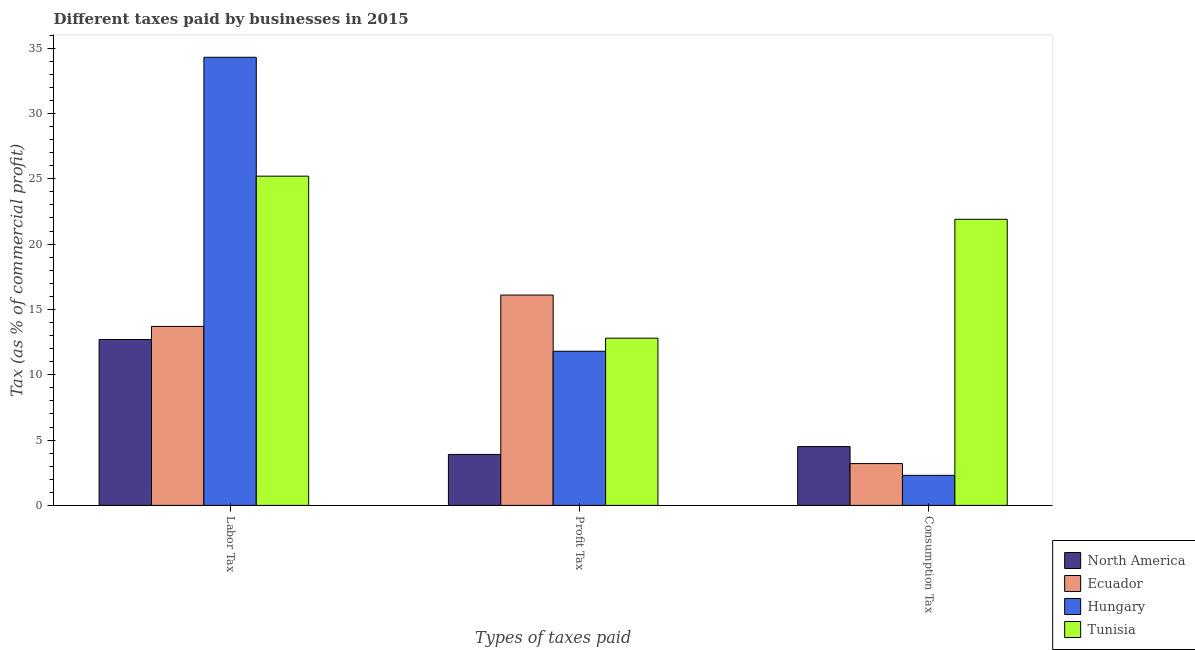How many different coloured bars are there?
Your answer should be compact. 4. How many groups of bars are there?
Your answer should be compact. 3. Are the number of bars per tick equal to the number of legend labels?
Make the answer very short. Yes. What is the label of the 3rd group of bars from the left?
Offer a terse response. Consumption Tax. What is the percentage of profit tax in Ecuador?
Give a very brief answer. 16.1. Across all countries, what is the maximum percentage of consumption tax?
Offer a very short reply. 21.9. In which country was the percentage of labor tax maximum?
Make the answer very short. Hungary. In which country was the percentage of labor tax minimum?
Make the answer very short. North America. What is the total percentage of labor tax in the graph?
Your response must be concise. 85.9. What is the difference between the percentage of labor tax in Tunisia and that in Ecuador?
Your answer should be very brief. 11.5. What is the average percentage of consumption tax per country?
Ensure brevity in your answer.  7.97. What is the difference between the percentage of consumption tax and percentage of profit tax in North America?
Offer a very short reply. 0.6. What is the ratio of the percentage of profit tax in North America to that in Ecuador?
Your answer should be very brief. 0.24. Is the percentage of consumption tax in Tunisia less than that in North America?
Ensure brevity in your answer.  No. What is the difference between the highest and the second highest percentage of labor tax?
Provide a short and direct response. 9.1. What is the difference between the highest and the lowest percentage of profit tax?
Keep it short and to the point. 12.2. In how many countries, is the percentage of profit tax greater than the average percentage of profit tax taken over all countries?
Make the answer very short. 3. Is the sum of the percentage of profit tax in Ecuador and Hungary greater than the maximum percentage of consumption tax across all countries?
Provide a short and direct response. Yes. What does the 3rd bar from the right in Labor Tax represents?
Offer a terse response. Ecuador. How many bars are there?
Provide a succinct answer. 12. Are all the bars in the graph horizontal?
Make the answer very short. No. Does the graph contain any zero values?
Your response must be concise. No. Does the graph contain grids?
Your answer should be very brief. No. Where does the legend appear in the graph?
Your response must be concise. Bottom right. How many legend labels are there?
Your answer should be compact. 4. How are the legend labels stacked?
Your response must be concise. Vertical. What is the title of the graph?
Give a very brief answer. Different taxes paid by businesses in 2015. Does "Central African Republic" appear as one of the legend labels in the graph?
Offer a terse response. No. What is the label or title of the X-axis?
Your answer should be compact. Types of taxes paid. What is the label or title of the Y-axis?
Give a very brief answer. Tax (as % of commercial profit). What is the Tax (as % of commercial profit) of North America in Labor Tax?
Your answer should be compact. 12.7. What is the Tax (as % of commercial profit) of Hungary in Labor Tax?
Provide a succinct answer. 34.3. What is the Tax (as % of commercial profit) of Tunisia in Labor Tax?
Provide a succinct answer. 25.2. What is the Tax (as % of commercial profit) in North America in Profit Tax?
Your answer should be compact. 3.9. What is the Tax (as % of commercial profit) in Tunisia in Profit Tax?
Offer a very short reply. 12.8. What is the Tax (as % of commercial profit) in North America in Consumption Tax?
Ensure brevity in your answer.  4.5. What is the Tax (as % of commercial profit) in Ecuador in Consumption Tax?
Your answer should be compact. 3.2. What is the Tax (as % of commercial profit) of Tunisia in Consumption Tax?
Make the answer very short. 21.9. Across all Types of taxes paid, what is the maximum Tax (as % of commercial profit) of Hungary?
Give a very brief answer. 34.3. Across all Types of taxes paid, what is the maximum Tax (as % of commercial profit) in Tunisia?
Give a very brief answer. 25.2. Across all Types of taxes paid, what is the minimum Tax (as % of commercial profit) of Tunisia?
Your response must be concise. 12.8. What is the total Tax (as % of commercial profit) in North America in the graph?
Offer a very short reply. 21.1. What is the total Tax (as % of commercial profit) in Hungary in the graph?
Your response must be concise. 48.4. What is the total Tax (as % of commercial profit) of Tunisia in the graph?
Keep it short and to the point. 59.9. What is the difference between the Tax (as % of commercial profit) in North America in Labor Tax and that in Profit Tax?
Provide a short and direct response. 8.8. What is the difference between the Tax (as % of commercial profit) of Ecuador in Labor Tax and that in Profit Tax?
Give a very brief answer. -2.4. What is the difference between the Tax (as % of commercial profit) of Hungary in Labor Tax and that in Profit Tax?
Provide a short and direct response. 22.5. What is the difference between the Tax (as % of commercial profit) of Tunisia in Labor Tax and that in Profit Tax?
Keep it short and to the point. 12.4. What is the difference between the Tax (as % of commercial profit) of North America in Labor Tax and that in Consumption Tax?
Your answer should be compact. 8.2. What is the difference between the Tax (as % of commercial profit) of Ecuador in Labor Tax and that in Consumption Tax?
Your response must be concise. 10.5. What is the difference between the Tax (as % of commercial profit) in Tunisia in Labor Tax and that in Consumption Tax?
Keep it short and to the point. 3.3. What is the difference between the Tax (as % of commercial profit) in North America in Profit Tax and that in Consumption Tax?
Ensure brevity in your answer.  -0.6. What is the difference between the Tax (as % of commercial profit) of Ecuador in Profit Tax and that in Consumption Tax?
Your answer should be very brief. 12.9. What is the difference between the Tax (as % of commercial profit) of Hungary in Profit Tax and that in Consumption Tax?
Your answer should be compact. 9.5. What is the difference between the Tax (as % of commercial profit) of Tunisia in Profit Tax and that in Consumption Tax?
Provide a short and direct response. -9.1. What is the difference between the Tax (as % of commercial profit) in North America in Labor Tax and the Tax (as % of commercial profit) in Hungary in Profit Tax?
Make the answer very short. 0.9. What is the difference between the Tax (as % of commercial profit) of North America in Labor Tax and the Tax (as % of commercial profit) of Tunisia in Profit Tax?
Your answer should be compact. -0.1. What is the difference between the Tax (as % of commercial profit) of Ecuador in Labor Tax and the Tax (as % of commercial profit) of Tunisia in Profit Tax?
Provide a succinct answer. 0.9. What is the difference between the Tax (as % of commercial profit) in North America in Labor Tax and the Tax (as % of commercial profit) in Ecuador in Consumption Tax?
Give a very brief answer. 9.5. What is the difference between the Tax (as % of commercial profit) of North America in Labor Tax and the Tax (as % of commercial profit) of Hungary in Consumption Tax?
Make the answer very short. 10.4. What is the difference between the Tax (as % of commercial profit) of Ecuador in Labor Tax and the Tax (as % of commercial profit) of Tunisia in Consumption Tax?
Give a very brief answer. -8.2. What is the difference between the Tax (as % of commercial profit) in North America in Profit Tax and the Tax (as % of commercial profit) in Hungary in Consumption Tax?
Provide a short and direct response. 1.6. What is the difference between the Tax (as % of commercial profit) in North America in Profit Tax and the Tax (as % of commercial profit) in Tunisia in Consumption Tax?
Offer a very short reply. -18. What is the difference between the Tax (as % of commercial profit) in Ecuador in Profit Tax and the Tax (as % of commercial profit) in Tunisia in Consumption Tax?
Offer a terse response. -5.8. What is the difference between the Tax (as % of commercial profit) of Hungary in Profit Tax and the Tax (as % of commercial profit) of Tunisia in Consumption Tax?
Your answer should be very brief. -10.1. What is the average Tax (as % of commercial profit) in North America per Types of taxes paid?
Your response must be concise. 7.03. What is the average Tax (as % of commercial profit) of Ecuador per Types of taxes paid?
Your answer should be very brief. 11. What is the average Tax (as % of commercial profit) in Hungary per Types of taxes paid?
Provide a short and direct response. 16.13. What is the average Tax (as % of commercial profit) in Tunisia per Types of taxes paid?
Your answer should be very brief. 19.97. What is the difference between the Tax (as % of commercial profit) of North America and Tax (as % of commercial profit) of Ecuador in Labor Tax?
Keep it short and to the point. -1. What is the difference between the Tax (as % of commercial profit) in North America and Tax (as % of commercial profit) in Hungary in Labor Tax?
Provide a succinct answer. -21.6. What is the difference between the Tax (as % of commercial profit) in Ecuador and Tax (as % of commercial profit) in Hungary in Labor Tax?
Make the answer very short. -20.6. What is the difference between the Tax (as % of commercial profit) in Ecuador and Tax (as % of commercial profit) in Tunisia in Labor Tax?
Provide a succinct answer. -11.5. What is the difference between the Tax (as % of commercial profit) in Hungary and Tax (as % of commercial profit) in Tunisia in Labor Tax?
Provide a succinct answer. 9.1. What is the difference between the Tax (as % of commercial profit) in North America and Tax (as % of commercial profit) in Ecuador in Profit Tax?
Provide a short and direct response. -12.2. What is the difference between the Tax (as % of commercial profit) in North America and Tax (as % of commercial profit) in Hungary in Profit Tax?
Your answer should be compact. -7.9. What is the difference between the Tax (as % of commercial profit) of North America and Tax (as % of commercial profit) of Tunisia in Profit Tax?
Your answer should be compact. -8.9. What is the difference between the Tax (as % of commercial profit) of Ecuador and Tax (as % of commercial profit) of Hungary in Profit Tax?
Make the answer very short. 4.3. What is the difference between the Tax (as % of commercial profit) in Hungary and Tax (as % of commercial profit) in Tunisia in Profit Tax?
Provide a short and direct response. -1. What is the difference between the Tax (as % of commercial profit) in North America and Tax (as % of commercial profit) in Ecuador in Consumption Tax?
Ensure brevity in your answer.  1.3. What is the difference between the Tax (as % of commercial profit) in North America and Tax (as % of commercial profit) in Hungary in Consumption Tax?
Your response must be concise. 2.2. What is the difference between the Tax (as % of commercial profit) of North America and Tax (as % of commercial profit) of Tunisia in Consumption Tax?
Provide a short and direct response. -17.4. What is the difference between the Tax (as % of commercial profit) of Ecuador and Tax (as % of commercial profit) of Tunisia in Consumption Tax?
Provide a succinct answer. -18.7. What is the difference between the Tax (as % of commercial profit) in Hungary and Tax (as % of commercial profit) in Tunisia in Consumption Tax?
Offer a terse response. -19.6. What is the ratio of the Tax (as % of commercial profit) of North America in Labor Tax to that in Profit Tax?
Your answer should be very brief. 3.26. What is the ratio of the Tax (as % of commercial profit) in Ecuador in Labor Tax to that in Profit Tax?
Ensure brevity in your answer.  0.85. What is the ratio of the Tax (as % of commercial profit) in Hungary in Labor Tax to that in Profit Tax?
Provide a succinct answer. 2.91. What is the ratio of the Tax (as % of commercial profit) of Tunisia in Labor Tax to that in Profit Tax?
Your answer should be compact. 1.97. What is the ratio of the Tax (as % of commercial profit) in North America in Labor Tax to that in Consumption Tax?
Make the answer very short. 2.82. What is the ratio of the Tax (as % of commercial profit) in Ecuador in Labor Tax to that in Consumption Tax?
Your answer should be compact. 4.28. What is the ratio of the Tax (as % of commercial profit) in Hungary in Labor Tax to that in Consumption Tax?
Make the answer very short. 14.91. What is the ratio of the Tax (as % of commercial profit) in Tunisia in Labor Tax to that in Consumption Tax?
Give a very brief answer. 1.15. What is the ratio of the Tax (as % of commercial profit) of North America in Profit Tax to that in Consumption Tax?
Make the answer very short. 0.87. What is the ratio of the Tax (as % of commercial profit) of Ecuador in Profit Tax to that in Consumption Tax?
Make the answer very short. 5.03. What is the ratio of the Tax (as % of commercial profit) of Hungary in Profit Tax to that in Consumption Tax?
Your answer should be very brief. 5.13. What is the ratio of the Tax (as % of commercial profit) of Tunisia in Profit Tax to that in Consumption Tax?
Your answer should be compact. 0.58. What is the difference between the highest and the second highest Tax (as % of commercial profit) of North America?
Offer a terse response. 8.2. What is the difference between the highest and the second highest Tax (as % of commercial profit) in Ecuador?
Provide a short and direct response. 2.4. What is the difference between the highest and the second highest Tax (as % of commercial profit) in Hungary?
Provide a succinct answer. 22.5. What is the difference between the highest and the lowest Tax (as % of commercial profit) of North America?
Provide a short and direct response. 8.8. What is the difference between the highest and the lowest Tax (as % of commercial profit) of Ecuador?
Offer a terse response. 12.9. What is the difference between the highest and the lowest Tax (as % of commercial profit) in Hungary?
Offer a very short reply. 32. 